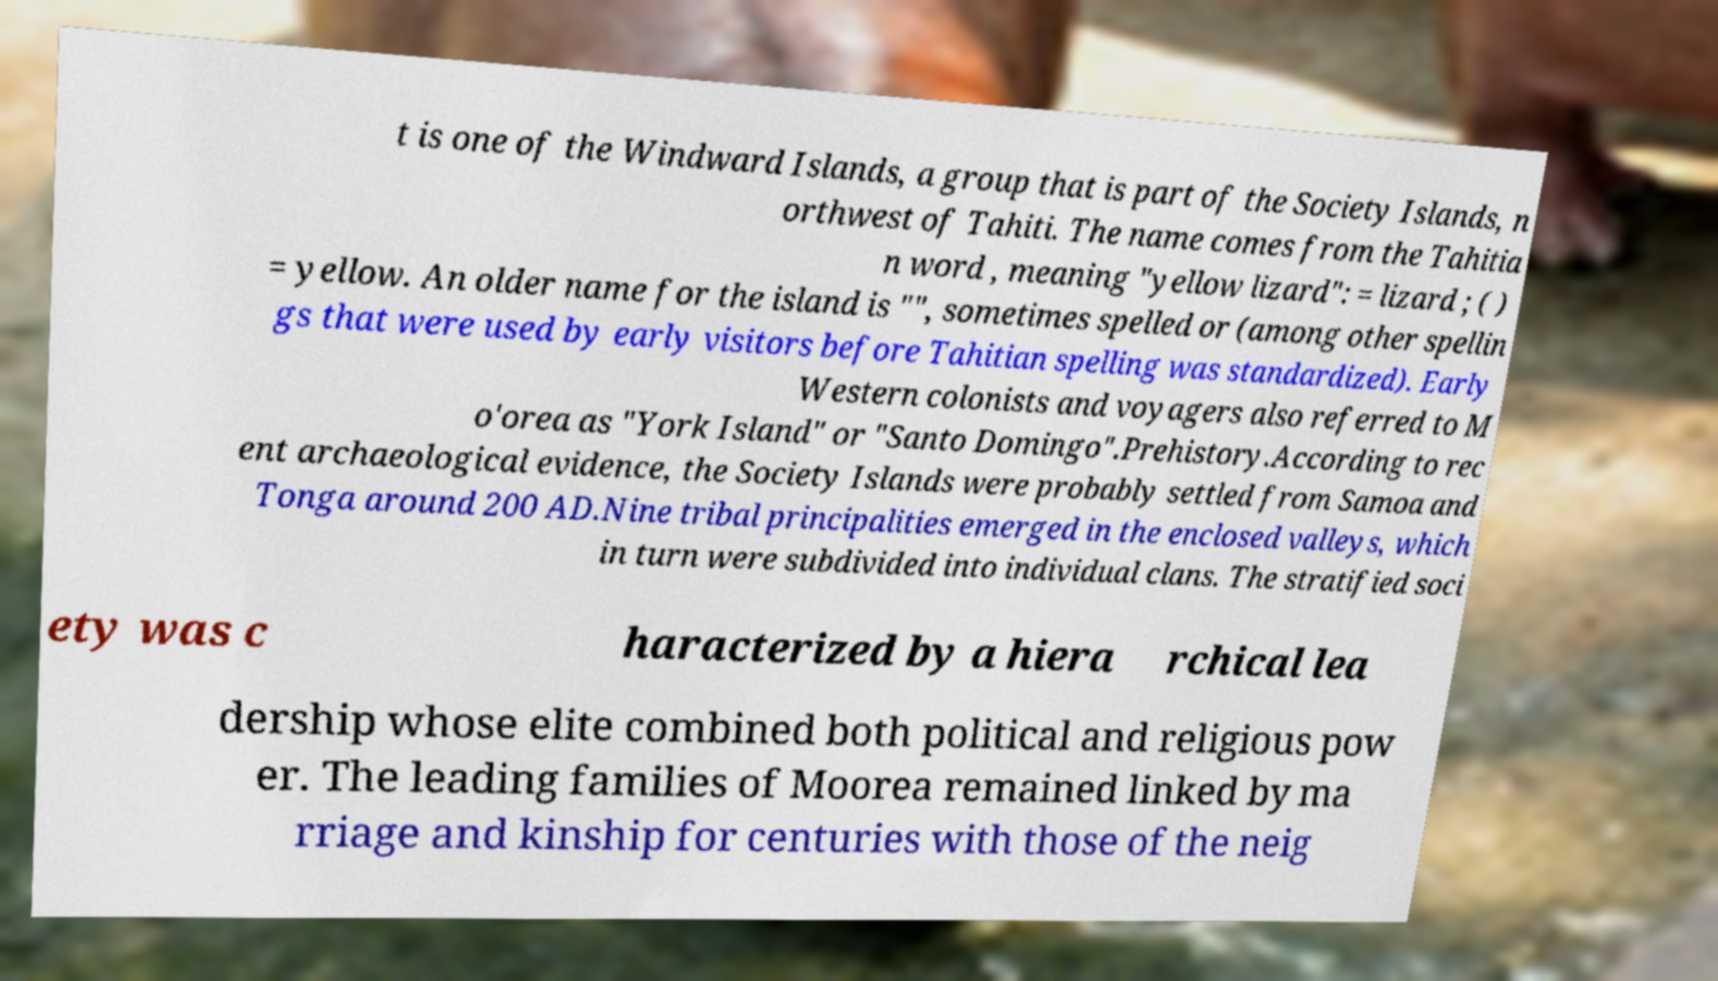Could you assist in decoding the text presented in this image and type it out clearly? t is one of the Windward Islands, a group that is part of the Society Islands, n orthwest of Tahiti. The name comes from the Tahitia n word , meaning "yellow lizard": = lizard ; ( ) = yellow. An older name for the island is "", sometimes spelled or (among other spellin gs that were used by early visitors before Tahitian spelling was standardized). Early Western colonists and voyagers also referred to M o'orea as "York Island" or "Santo Domingo".Prehistory.According to rec ent archaeological evidence, the Society Islands were probably settled from Samoa and Tonga around 200 AD.Nine tribal principalities emerged in the enclosed valleys, which in turn were subdivided into individual clans. The stratified soci ety was c haracterized by a hiera rchical lea dership whose elite combined both political and religious pow er. The leading families of Moorea remained linked by ma rriage and kinship for centuries with those of the neig 